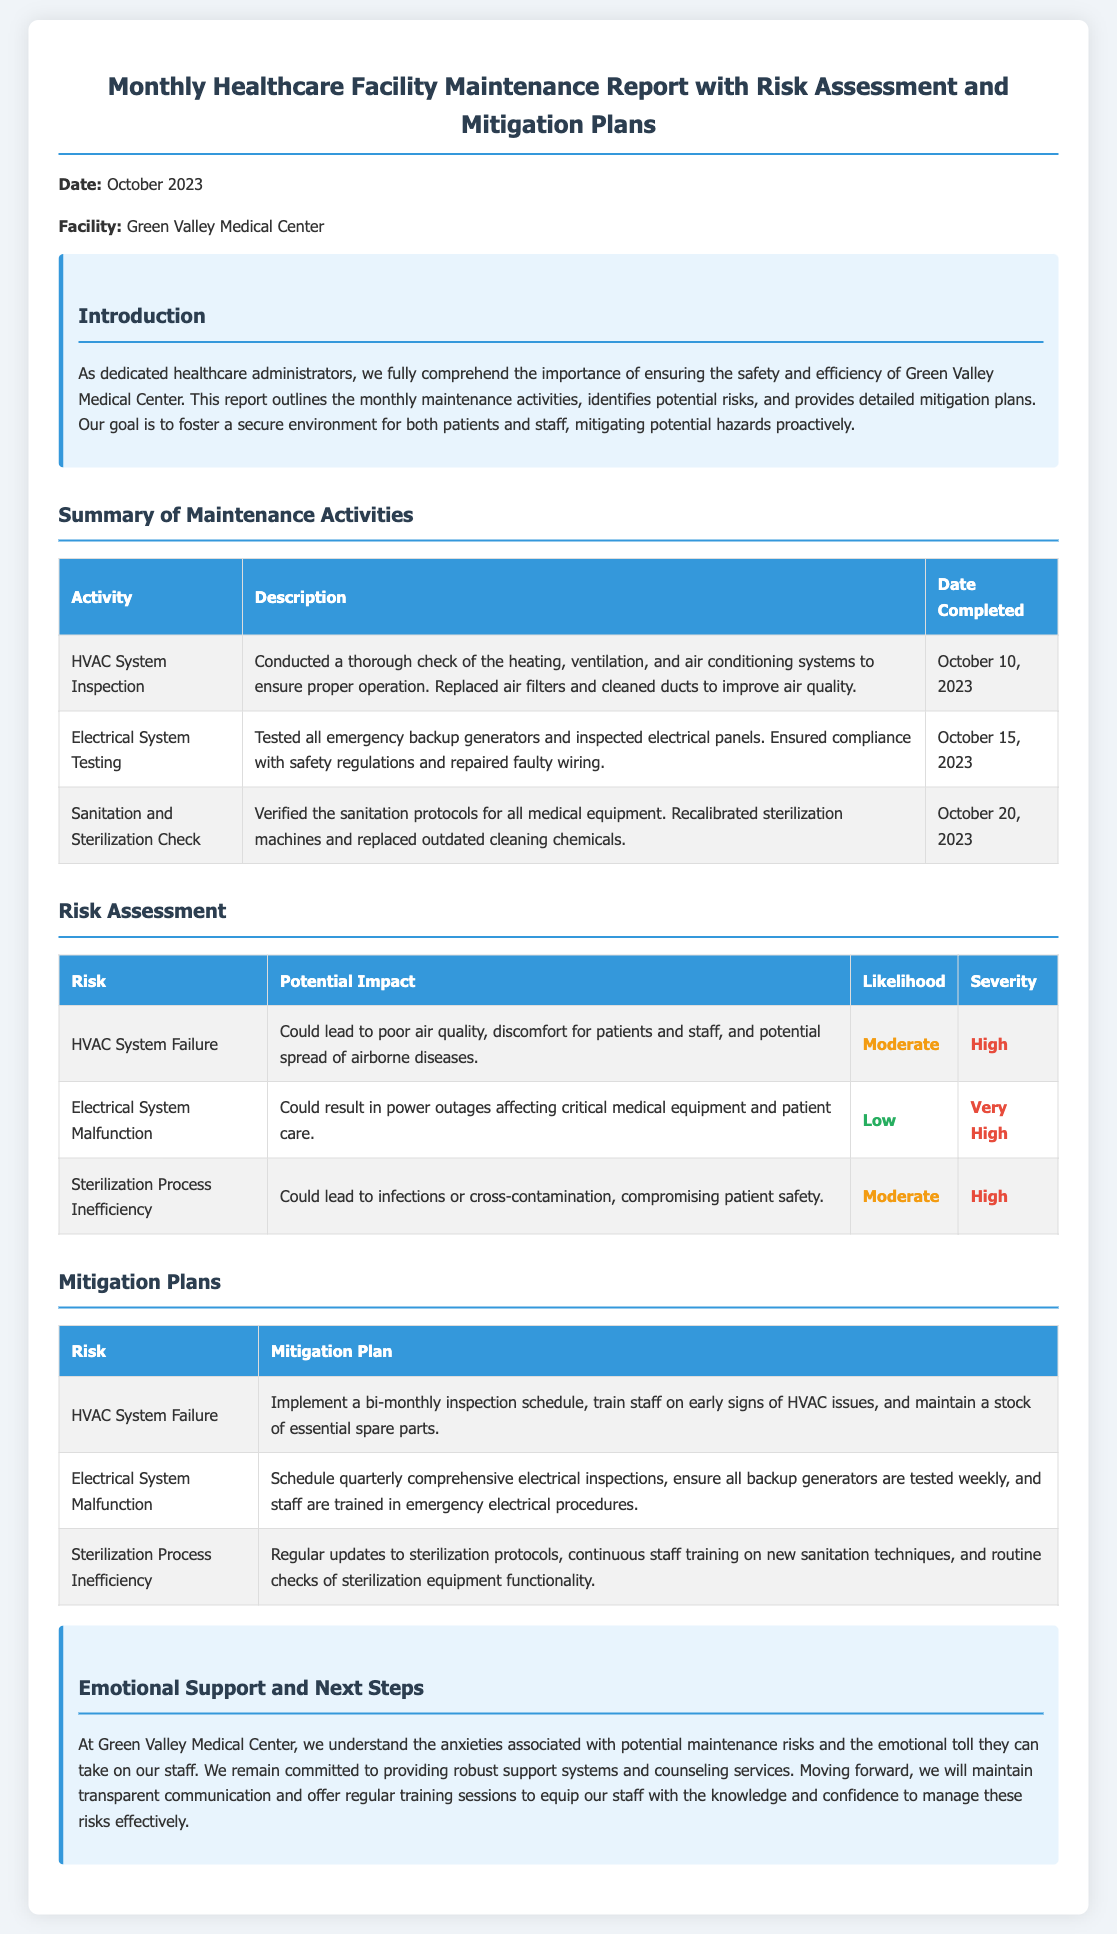what is the report title? The title of the document is clearly stated at the beginning of the report.
Answer: Monthly Healthcare Facility Maintenance Report with Risk Assessment and Mitigation Plans which facility does the report pertain to? The report specifies the name of the facility in the introductory section.
Answer: Green Valley Medical Center what date was the HVAC System Inspection completed? The date for the HVAC System Inspection is provided in the summary of maintenance activities table.
Answer: October 10, 2023 what is the potential impact of HVAC System Failure? The potential impact of HVAC System Failure is explained in the risk assessment section of the document.
Answer: Could lead to poor air quality, discomfort for patients and staff, and potential spread of airborne diseases what is the likelihood of the Electrical System Malfunction risk? The likelihood of Electrical System Malfunction is classified in the risk assessment table.
Answer: Low what mitigation plan is suggested for Sterilization Process Inefficiency? This information is outlined in the mitigation plans table.
Answer: Regular updates to sterilization protocols, continuous staff training on new sanitation techniques, and routine checks of sterilization equipment functionality what support does the facility offer to staff regarding maintenance risks? The document discusses emotional support in the support section, addressing staff concerns related to maintenance risks.
Answer: Robust support systems and counseling services what is the main goal of the report? The introduction outlines the primary goal of the report.
Answer: Foster a secure environment for both patients and staff, mitigating potential hazards proactively 